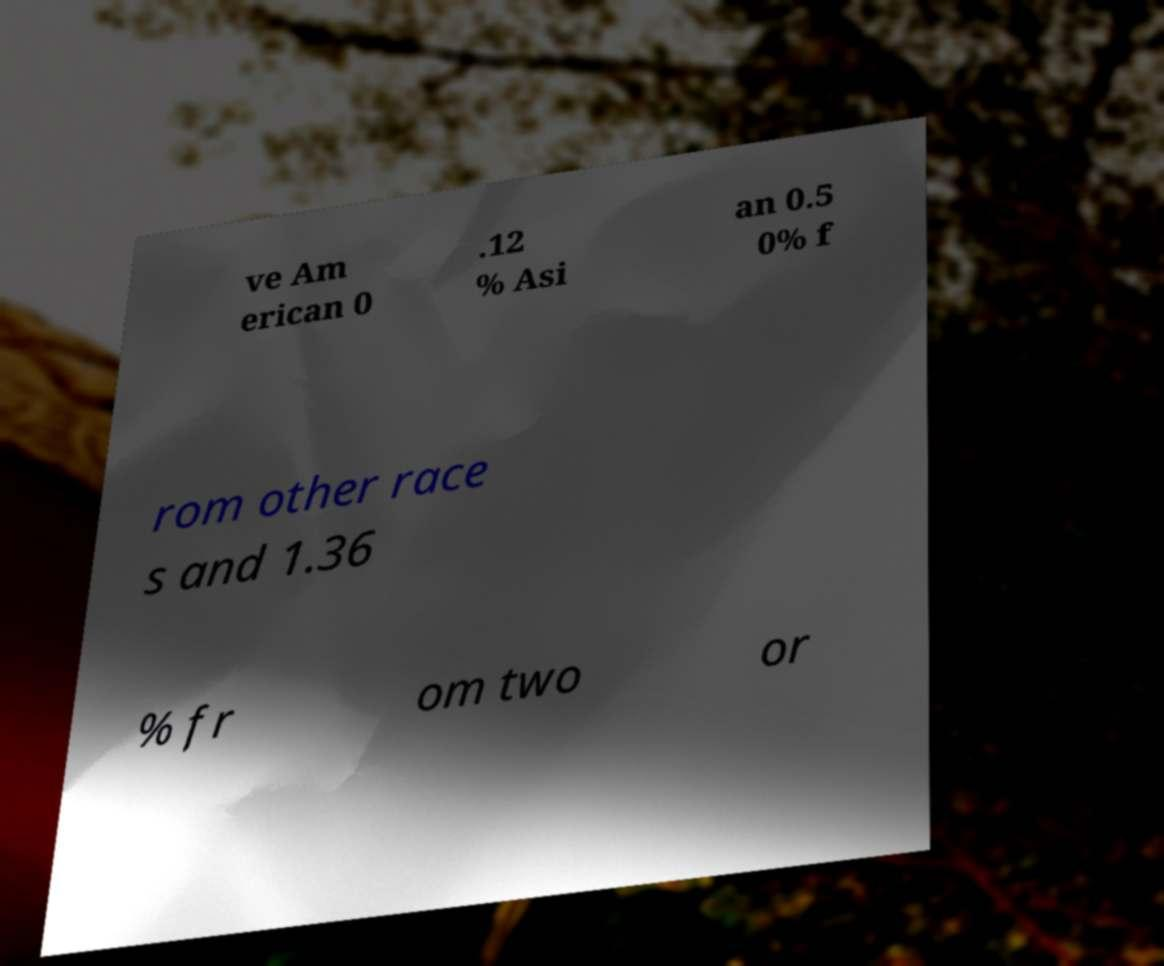There's text embedded in this image that I need extracted. Can you transcribe it verbatim? ve Am erican 0 .12 % Asi an 0.5 0% f rom other race s and 1.36 % fr om two or 